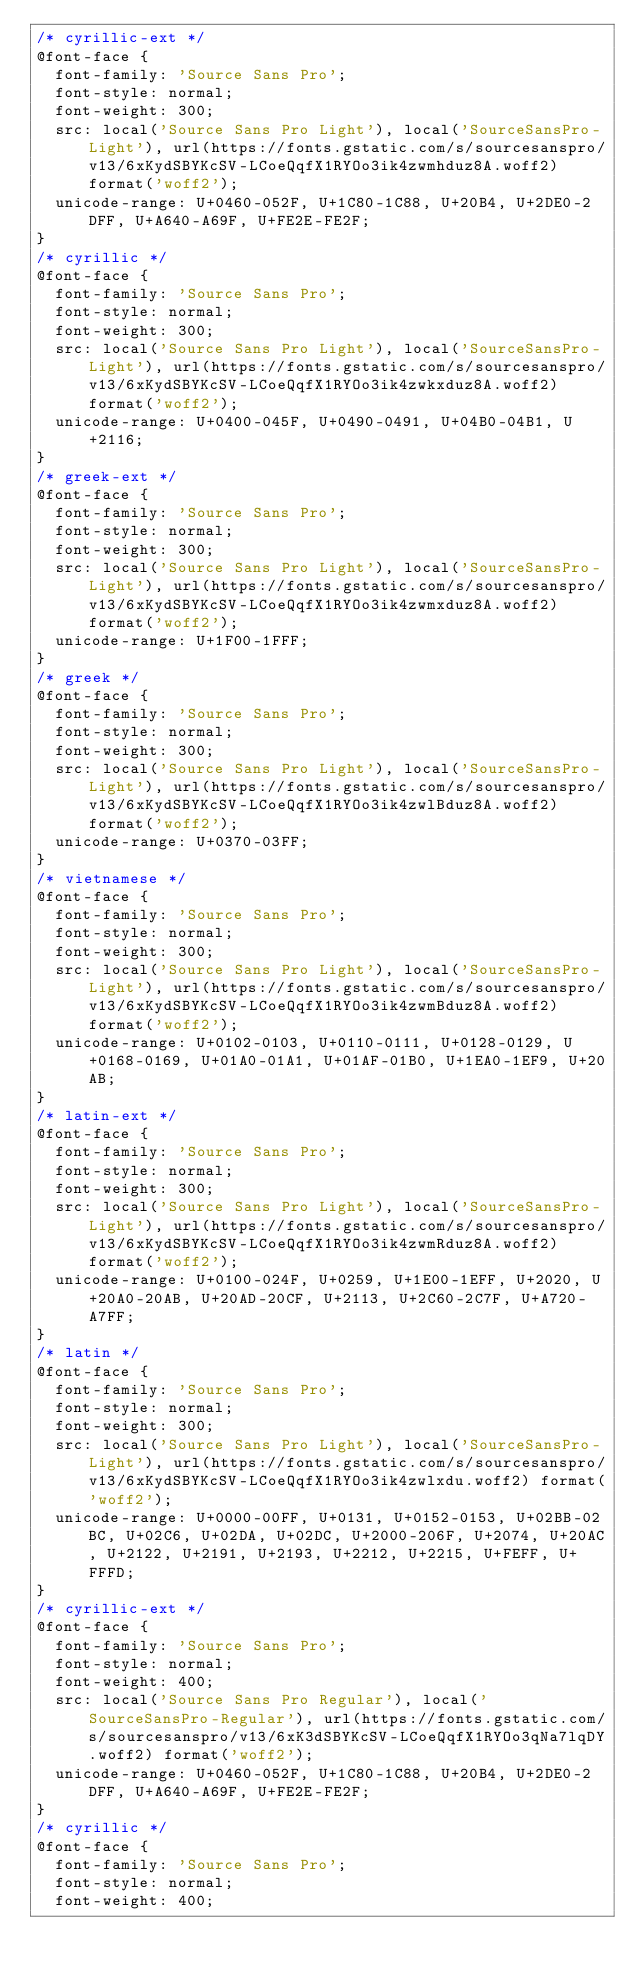Convert code to text. <code><loc_0><loc_0><loc_500><loc_500><_CSS_>/* cyrillic-ext */
@font-face {
  font-family: 'Source Sans Pro';
  font-style: normal;
  font-weight: 300;
  src: local('Source Sans Pro Light'), local('SourceSansPro-Light'), url(https://fonts.gstatic.com/s/sourcesanspro/v13/6xKydSBYKcSV-LCoeQqfX1RYOo3ik4zwmhduz8A.woff2) format('woff2');
  unicode-range: U+0460-052F, U+1C80-1C88, U+20B4, U+2DE0-2DFF, U+A640-A69F, U+FE2E-FE2F;
}
/* cyrillic */
@font-face {
  font-family: 'Source Sans Pro';
  font-style: normal;
  font-weight: 300;
  src: local('Source Sans Pro Light'), local('SourceSansPro-Light'), url(https://fonts.gstatic.com/s/sourcesanspro/v13/6xKydSBYKcSV-LCoeQqfX1RYOo3ik4zwkxduz8A.woff2) format('woff2');
  unicode-range: U+0400-045F, U+0490-0491, U+04B0-04B1, U+2116;
}
/* greek-ext */
@font-face {
  font-family: 'Source Sans Pro';
  font-style: normal;
  font-weight: 300;
  src: local('Source Sans Pro Light'), local('SourceSansPro-Light'), url(https://fonts.gstatic.com/s/sourcesanspro/v13/6xKydSBYKcSV-LCoeQqfX1RYOo3ik4zwmxduz8A.woff2) format('woff2');
  unicode-range: U+1F00-1FFF;
}
/* greek */
@font-face {
  font-family: 'Source Sans Pro';
  font-style: normal;
  font-weight: 300;
  src: local('Source Sans Pro Light'), local('SourceSansPro-Light'), url(https://fonts.gstatic.com/s/sourcesanspro/v13/6xKydSBYKcSV-LCoeQqfX1RYOo3ik4zwlBduz8A.woff2) format('woff2');
  unicode-range: U+0370-03FF;
}
/* vietnamese */
@font-face {
  font-family: 'Source Sans Pro';
  font-style: normal;
  font-weight: 300;
  src: local('Source Sans Pro Light'), local('SourceSansPro-Light'), url(https://fonts.gstatic.com/s/sourcesanspro/v13/6xKydSBYKcSV-LCoeQqfX1RYOo3ik4zwmBduz8A.woff2) format('woff2');
  unicode-range: U+0102-0103, U+0110-0111, U+0128-0129, U+0168-0169, U+01A0-01A1, U+01AF-01B0, U+1EA0-1EF9, U+20AB;
}
/* latin-ext */
@font-face {
  font-family: 'Source Sans Pro';
  font-style: normal;
  font-weight: 300;
  src: local('Source Sans Pro Light'), local('SourceSansPro-Light'), url(https://fonts.gstatic.com/s/sourcesanspro/v13/6xKydSBYKcSV-LCoeQqfX1RYOo3ik4zwmRduz8A.woff2) format('woff2');
  unicode-range: U+0100-024F, U+0259, U+1E00-1EFF, U+2020, U+20A0-20AB, U+20AD-20CF, U+2113, U+2C60-2C7F, U+A720-A7FF;
}
/* latin */
@font-face {
  font-family: 'Source Sans Pro';
  font-style: normal;
  font-weight: 300;
  src: local('Source Sans Pro Light'), local('SourceSansPro-Light'), url(https://fonts.gstatic.com/s/sourcesanspro/v13/6xKydSBYKcSV-LCoeQqfX1RYOo3ik4zwlxdu.woff2) format('woff2');
  unicode-range: U+0000-00FF, U+0131, U+0152-0153, U+02BB-02BC, U+02C6, U+02DA, U+02DC, U+2000-206F, U+2074, U+20AC, U+2122, U+2191, U+2193, U+2212, U+2215, U+FEFF, U+FFFD;
}
/* cyrillic-ext */
@font-face {
  font-family: 'Source Sans Pro';
  font-style: normal;
  font-weight: 400;
  src: local('Source Sans Pro Regular'), local('SourceSansPro-Regular'), url(https://fonts.gstatic.com/s/sourcesanspro/v13/6xK3dSBYKcSV-LCoeQqfX1RYOo3qNa7lqDY.woff2) format('woff2');
  unicode-range: U+0460-052F, U+1C80-1C88, U+20B4, U+2DE0-2DFF, U+A640-A69F, U+FE2E-FE2F;
}
/* cyrillic */
@font-face {
  font-family: 'Source Sans Pro';
  font-style: normal;
  font-weight: 400;</code> 